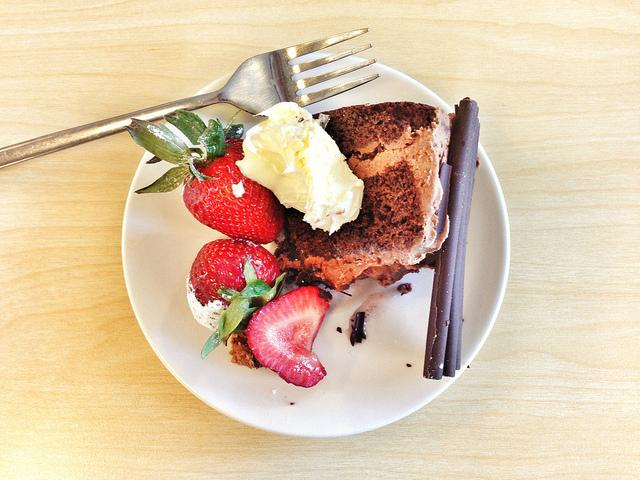What kind of fruit is there a serving of to the side of the cake? Please explain your reasoning. strawbery. The fruit is a large red berry with a green stem. 